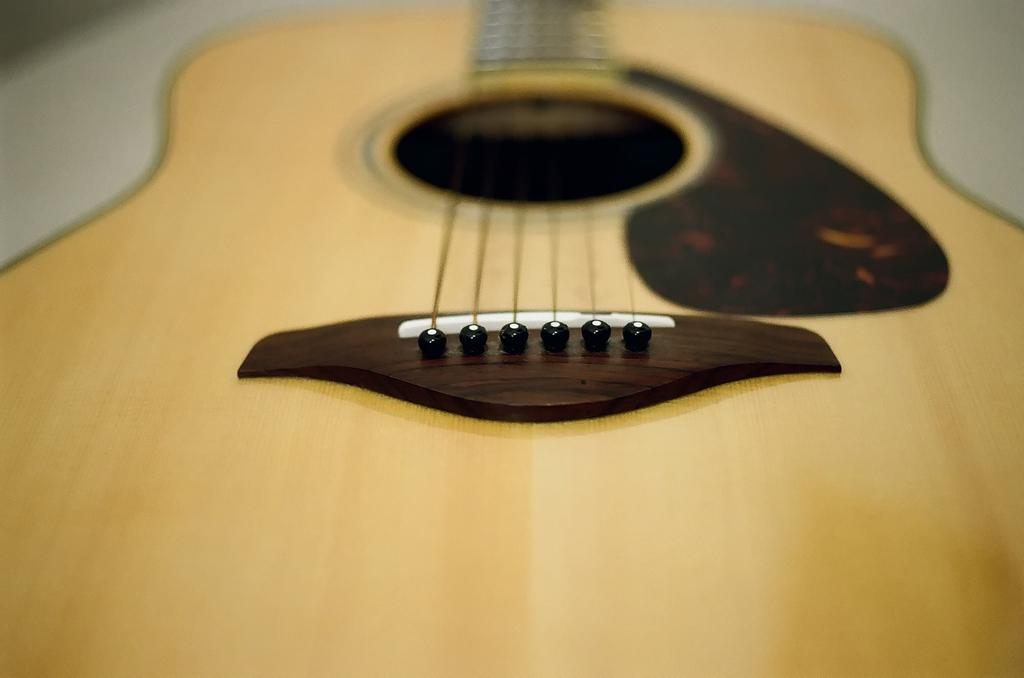What is the main object in the picture? There is a guitar in the picture. How many strings does the guitar have? The guitar has six strings. What type of condition is the sack in within the image? There is no sack present in the image, so it is not possible to determine the condition of a sack. 